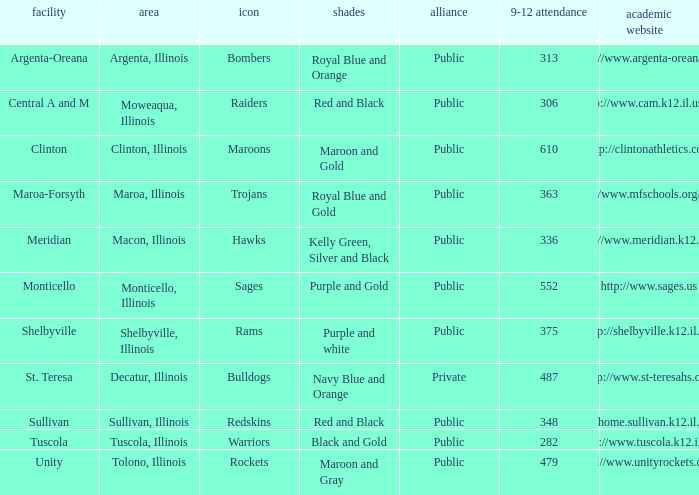What colors can you see players from Tolono, Illinois wearing? Maroon and Gray. 